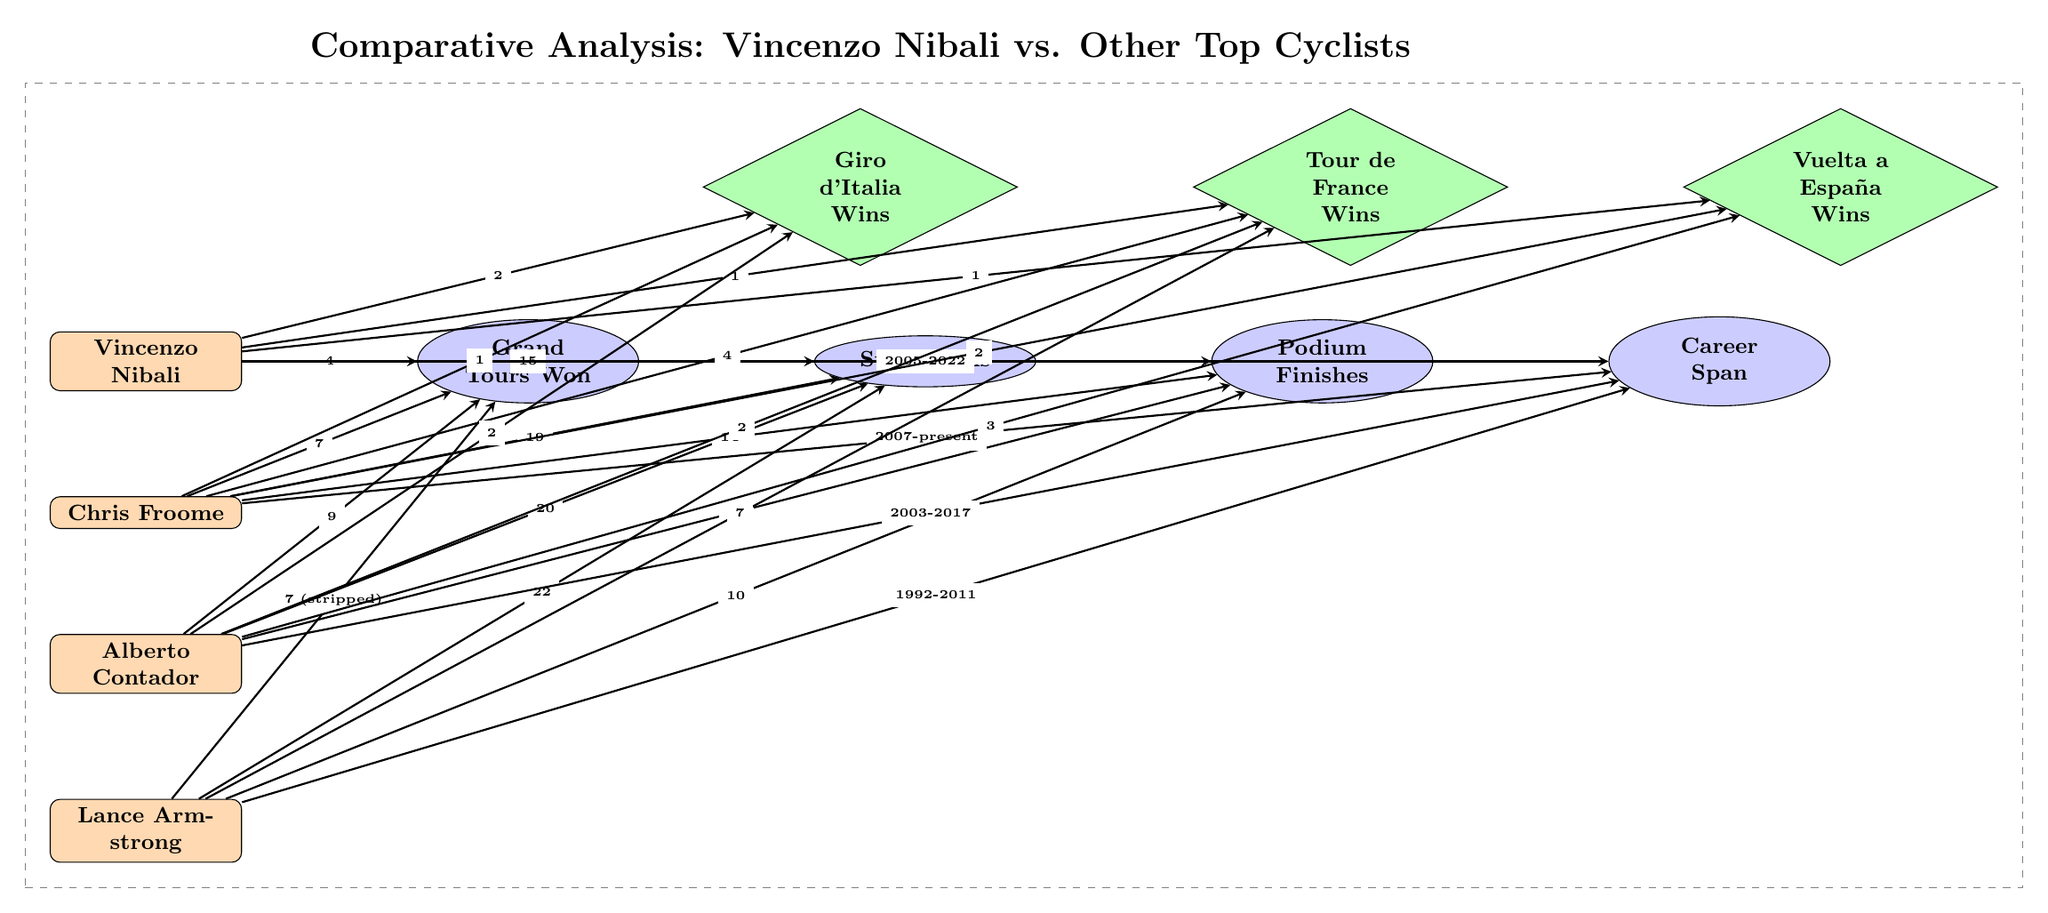What's the total number of Grand Tours won by Vincenzo Nibali? In the diagram, the value connected to the "Grand Tours Won" node for Vincenzo Nibali is "4". This is gathered directly from the connection between Nibali and the "Grand Tours Won" statistic.
Answer: 4 How many stage wins does Chris Froome have? The diagram shows that Chris Froome has "19" stage wins, which can be found along the connecting edge from Froome to the "Stage Wins" node.
Answer: 19 What is the total number of podium finishes for Alberto Contador? By observing the connection between Alberto Contador and the "Podium Finishes" node, we see that the value is "13", indicating the total number of podium finishes he achieved.
Answer: 13 Which cyclist has the most Grand Tours won according to the diagram? The diagram shows the Grand Tours won by each cyclist, with Alberto Contador at "9", Chris Froome at "7", and Vincenzo Nibali at "4". Thus, Alberto Contador has the highest number of Grand Tours won in the comparison.
Answer: Alberto Contador What years did Vincenzo Nibali's professional career span? The diagram indicates that Vincenzo Nibali's career spans from "2005" to "2022", as shown in the connection between him and the "Career Span" node.
Answer: 2005-2022 How many Tour de France wins does Chris Froome have? Looking at the connections related to the "Tour de France Wins" node, it states that Chris Froome has "4" wins in that specific race, which can be directly read from the diagram.
Answer: 4 Which cyclist has the least podium finishes? By reviewing the podium finishes for each cyclist, Vincenzo Nibali has "11", Chris Froome has "14", Alberto Contador has "13", and Lance Armstrong has "10". The lowest number of podium finishes is associated with Lance Armstrong, who has "10".
Answer: Lance Armstrong What is the total number of stage wins among all cyclists? To get this total, we add the stage wins for each cyclist: Nibali (15) + Froome (19) + Contador (20) + Armstrong (22) equals 76 stage wins. This calculation is done by tracing the respective connections to the "Stage Wins" statistic node for each cyclist.
Answer: 76 How many Vuelta a España wins does Vincenzo Nibali have? The diagram clearly indicates that Vincenzo Nibali has "1" win in the Vuelta a España, directly linked to the corresponding statistic node for him.
Answer: 1 